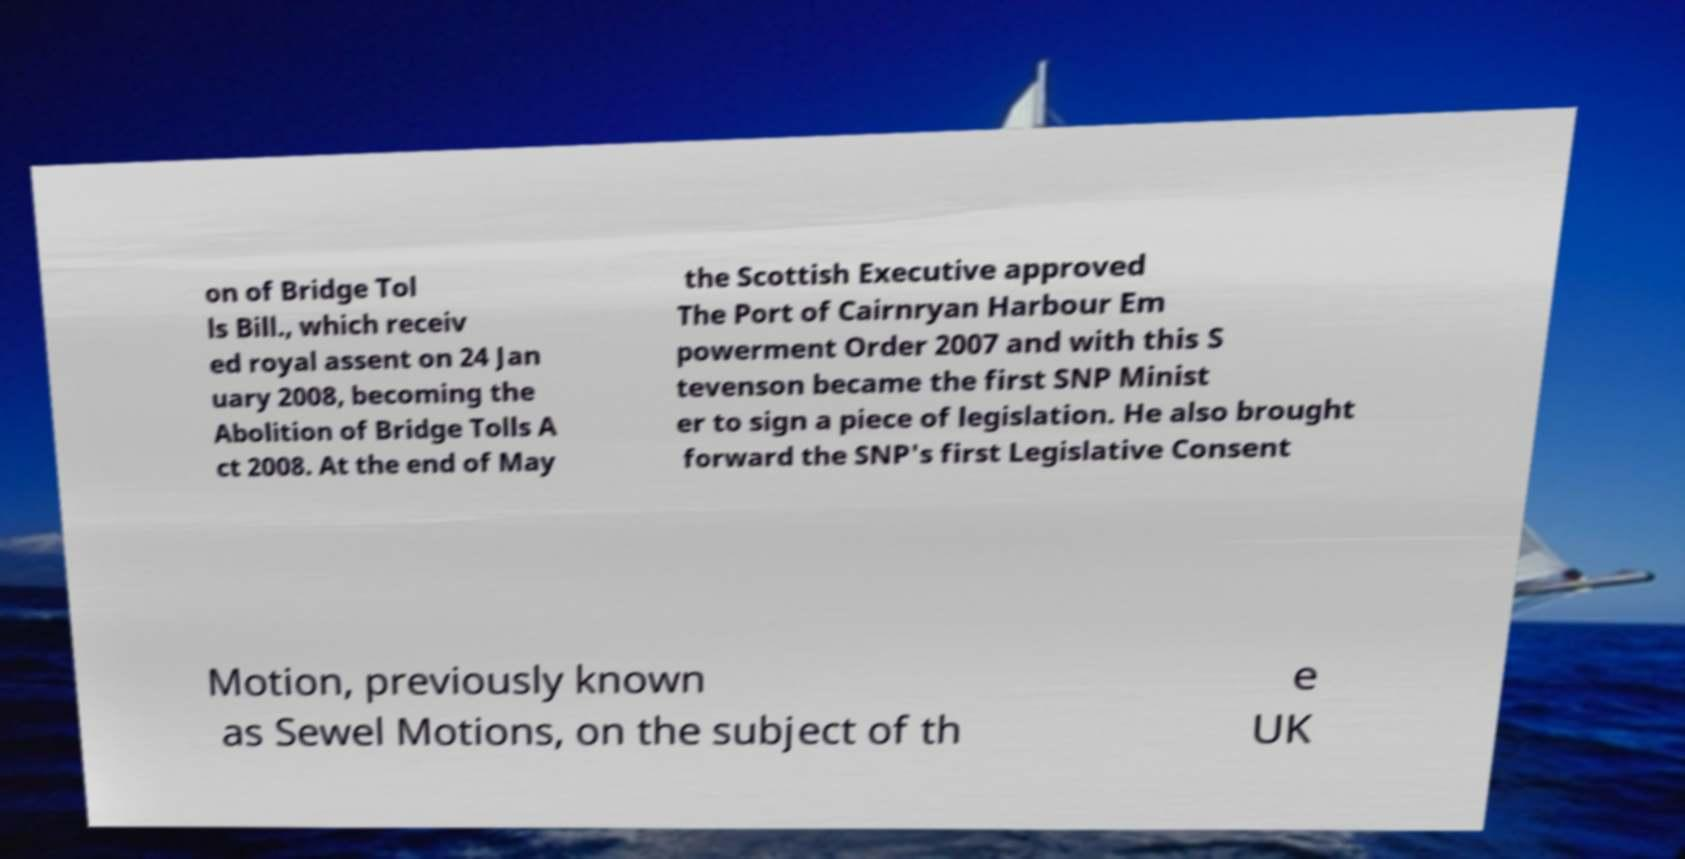What messages or text are displayed in this image? I need them in a readable, typed format. on of Bridge Tol ls Bill., which receiv ed royal assent on 24 Jan uary 2008, becoming the Abolition of Bridge Tolls A ct 2008. At the end of May the Scottish Executive approved The Port of Cairnryan Harbour Em powerment Order 2007 and with this S tevenson became the first SNP Minist er to sign a piece of legislation. He also brought forward the SNP's first Legislative Consent Motion, previously known as Sewel Motions, on the subject of th e UK 